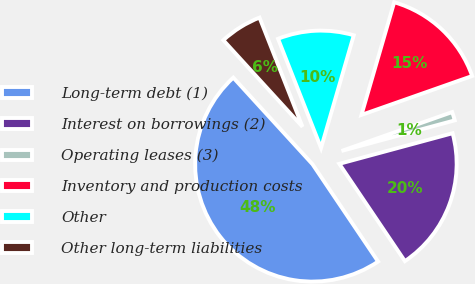Convert chart. <chart><loc_0><loc_0><loc_500><loc_500><pie_chart><fcel>Long-term debt (1)<fcel>Interest on borrowings (2)<fcel>Operating leases (3)<fcel>Inventory and production costs<fcel>Other<fcel>Other long-term liabilities<nl><fcel>47.65%<fcel>19.76%<fcel>1.18%<fcel>15.12%<fcel>10.47%<fcel>5.82%<nl></chart> 